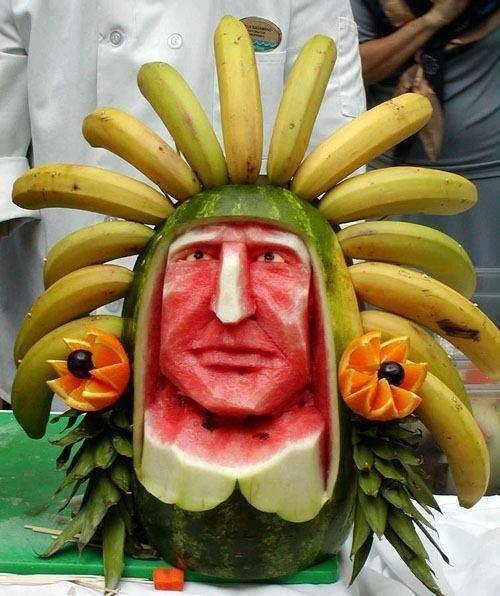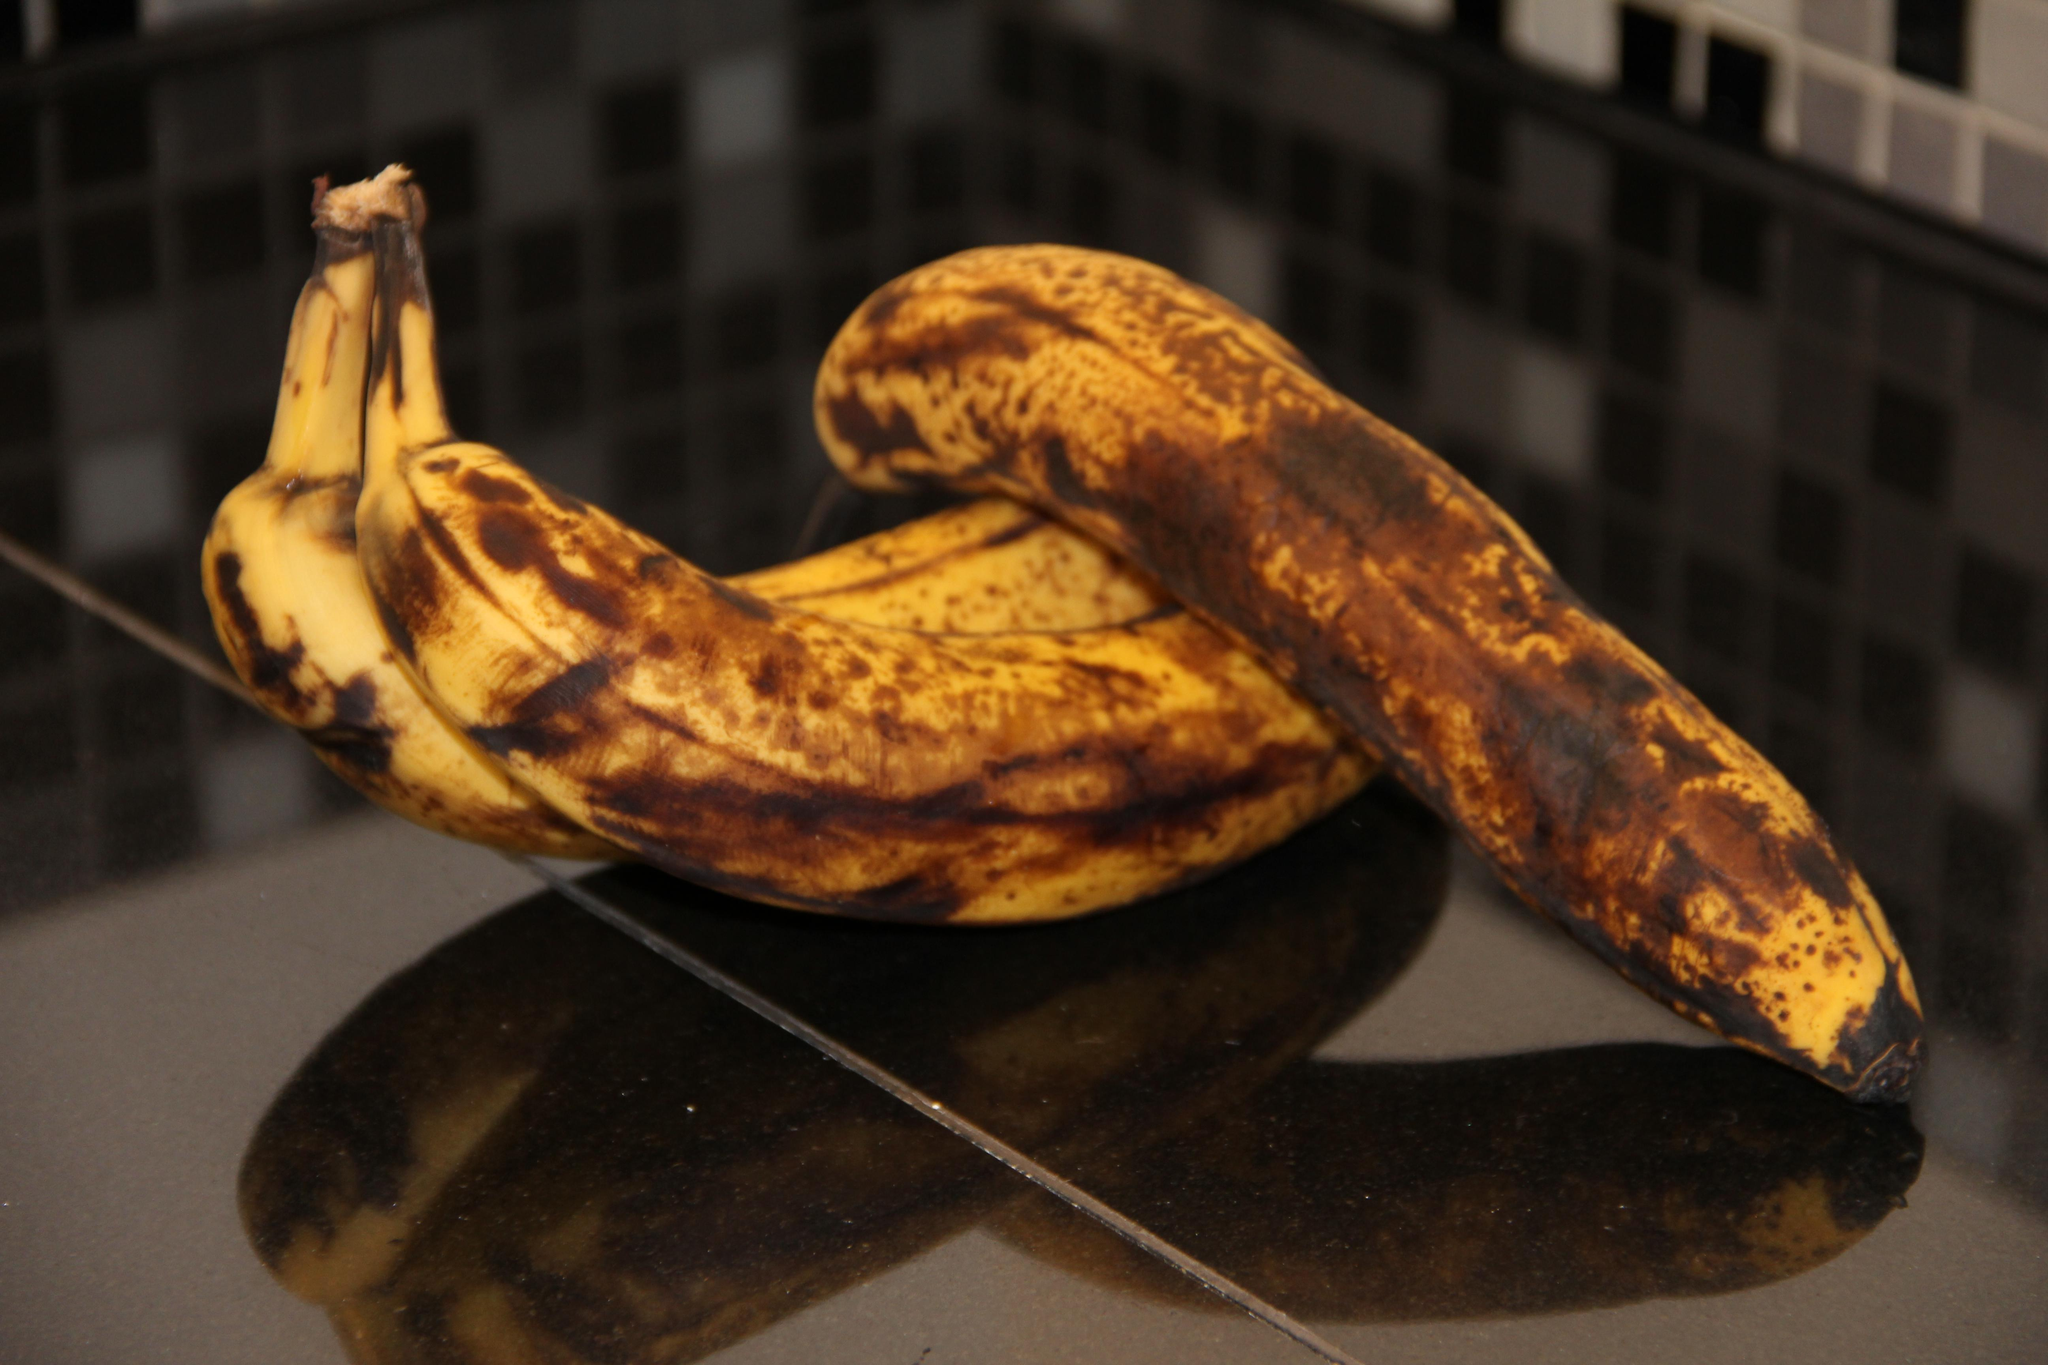The first image is the image on the left, the second image is the image on the right. For the images shown, is this caption "In the left image bananas are displayed with at least one other type of fruit." true? Answer yes or no. Yes. The first image is the image on the left, the second image is the image on the right. For the images shown, is this caption "The right image shows only overripe, brownish-yellow bananas with their peels intact, and the left image includes bananas and at least one other type of fruit." true? Answer yes or no. Yes. 